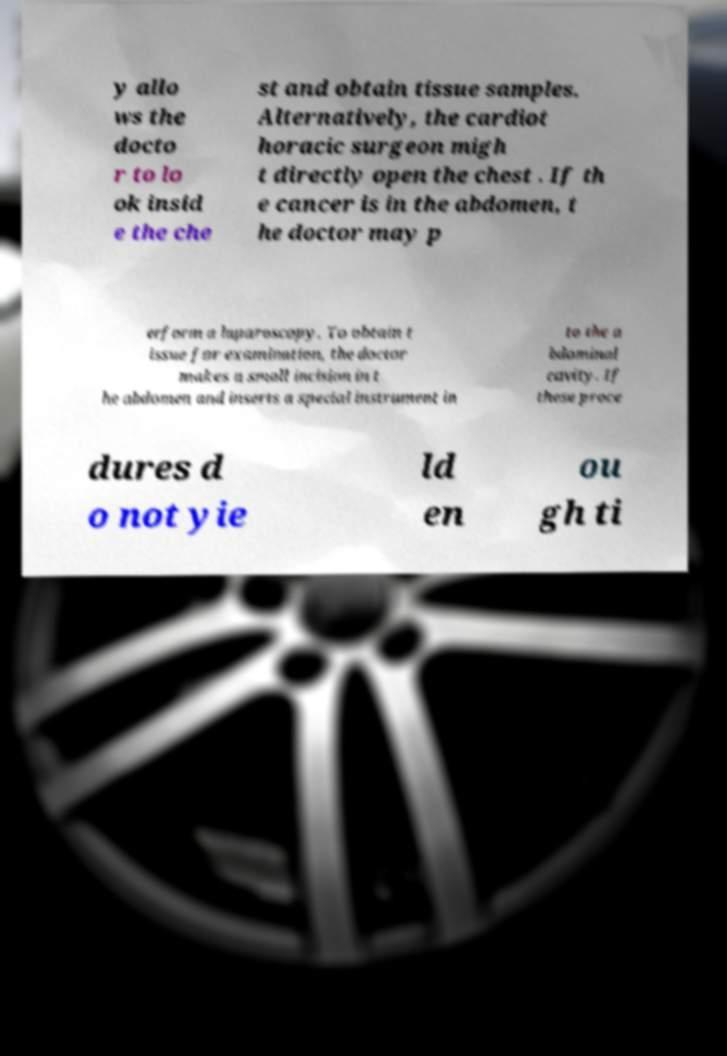I need the written content from this picture converted into text. Can you do that? y allo ws the docto r to lo ok insid e the che st and obtain tissue samples. Alternatively, the cardiot horacic surgeon migh t directly open the chest . If th e cancer is in the abdomen, t he doctor may p erform a laparoscopy. To obtain t issue for examination, the doctor makes a small incision in t he abdomen and inserts a special instrument in to the a bdominal cavity. If these proce dures d o not yie ld en ou gh ti 